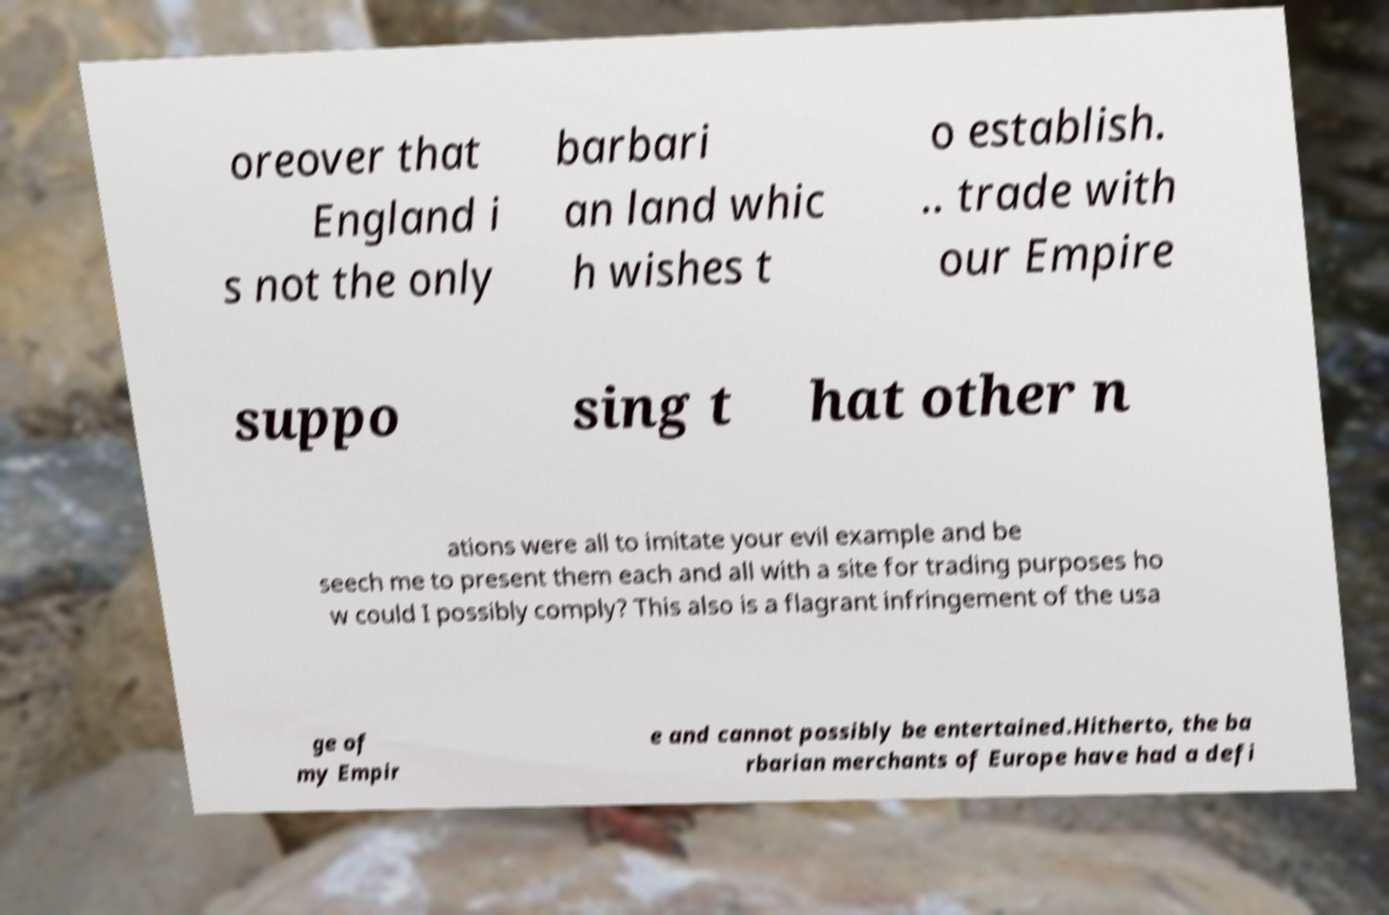For documentation purposes, I need the text within this image transcribed. Could you provide that? oreover that England i s not the only barbari an land whic h wishes t o establish. .. trade with our Empire suppo sing t hat other n ations were all to imitate your evil example and be seech me to present them each and all with a site for trading purposes ho w could I possibly comply? This also is a flagrant infringement of the usa ge of my Empir e and cannot possibly be entertained.Hitherto, the ba rbarian merchants of Europe have had a defi 